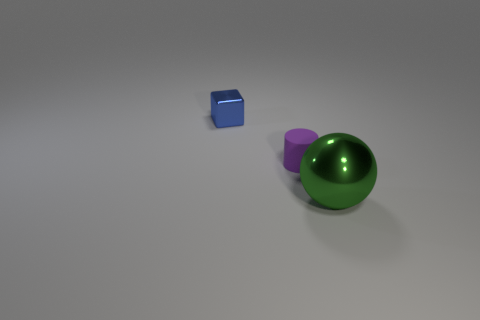Add 3 purple matte cylinders. How many objects exist? 6 Subtract all spheres. How many objects are left? 2 Add 2 big green rubber cubes. How many big green rubber cubes exist? 2 Subtract 0 red cylinders. How many objects are left? 3 Subtract all small purple cylinders. Subtract all small cylinders. How many objects are left? 1 Add 3 tiny blocks. How many tiny blocks are left? 4 